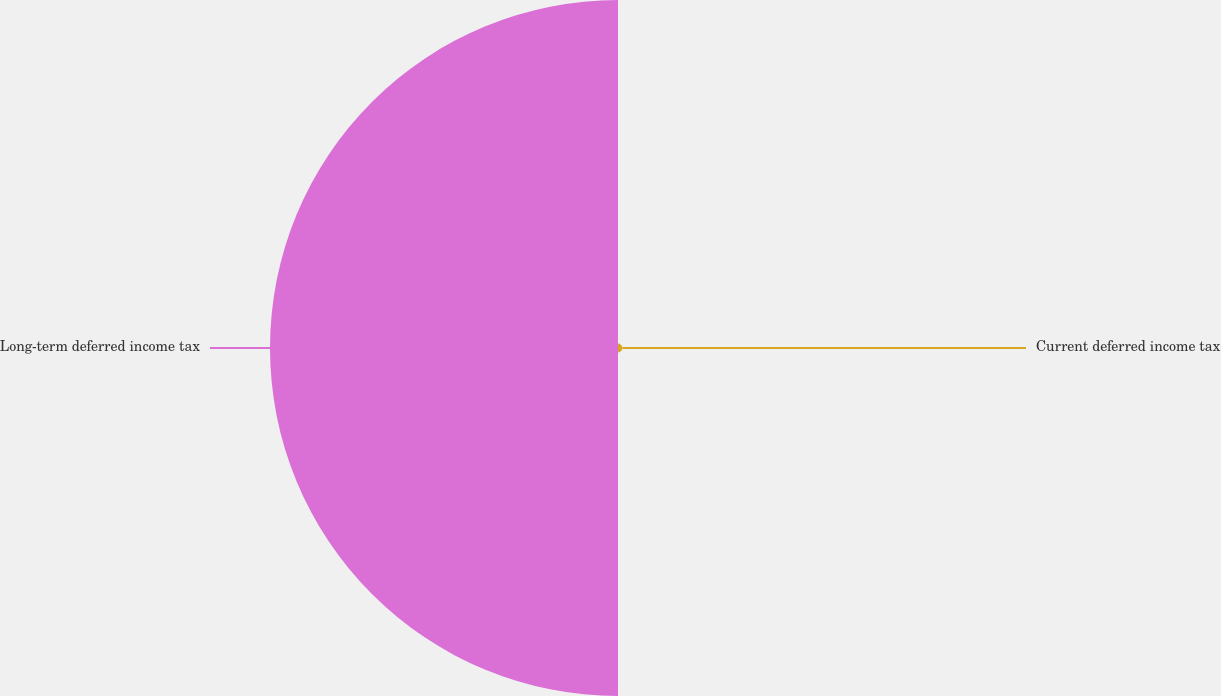Convert chart to OTSL. <chart><loc_0><loc_0><loc_500><loc_500><pie_chart><fcel>Current deferred income tax<fcel>Long-term deferred income tax<nl><fcel>1.25%<fcel>98.75%<nl></chart> 